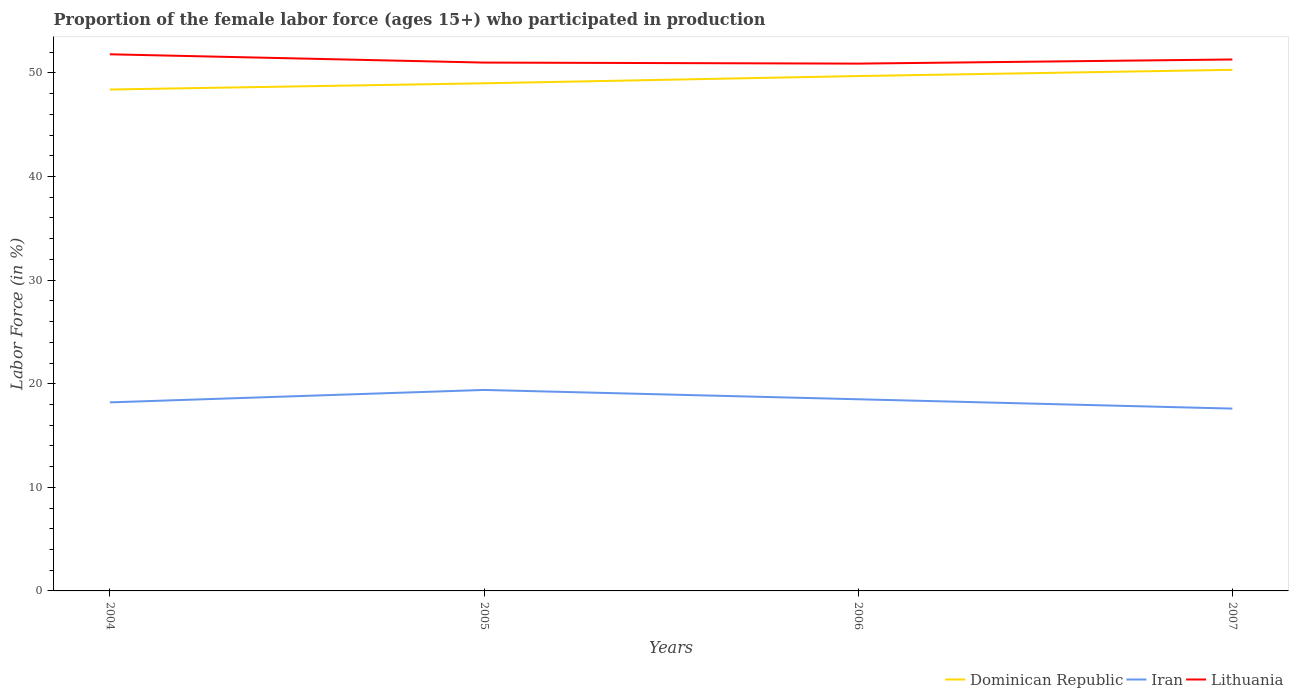How many different coloured lines are there?
Give a very brief answer. 3. Does the line corresponding to Lithuania intersect with the line corresponding to Dominican Republic?
Offer a very short reply. No. Is the number of lines equal to the number of legend labels?
Offer a very short reply. Yes. Across all years, what is the maximum proportion of the female labor force who participated in production in Dominican Republic?
Provide a short and direct response. 48.4. In which year was the proportion of the female labor force who participated in production in Iran maximum?
Ensure brevity in your answer.  2007. What is the total proportion of the female labor force who participated in production in Lithuania in the graph?
Provide a short and direct response. 0.5. What is the difference between the highest and the second highest proportion of the female labor force who participated in production in Iran?
Ensure brevity in your answer.  1.8. What is the difference between the highest and the lowest proportion of the female labor force who participated in production in Iran?
Offer a very short reply. 2. How many years are there in the graph?
Give a very brief answer. 4. What is the difference between two consecutive major ticks on the Y-axis?
Ensure brevity in your answer.  10. Are the values on the major ticks of Y-axis written in scientific E-notation?
Your answer should be compact. No. Where does the legend appear in the graph?
Provide a succinct answer. Bottom right. How are the legend labels stacked?
Make the answer very short. Horizontal. What is the title of the graph?
Make the answer very short. Proportion of the female labor force (ages 15+) who participated in production. What is the Labor Force (in %) in Dominican Republic in 2004?
Offer a very short reply. 48.4. What is the Labor Force (in %) in Iran in 2004?
Provide a succinct answer. 18.2. What is the Labor Force (in %) of Lithuania in 2004?
Your response must be concise. 51.8. What is the Labor Force (in %) in Iran in 2005?
Provide a succinct answer. 19.4. What is the Labor Force (in %) in Lithuania in 2005?
Make the answer very short. 51. What is the Labor Force (in %) in Dominican Republic in 2006?
Your answer should be compact. 49.7. What is the Labor Force (in %) in Iran in 2006?
Your answer should be compact. 18.5. What is the Labor Force (in %) in Lithuania in 2006?
Give a very brief answer. 50.9. What is the Labor Force (in %) of Dominican Republic in 2007?
Give a very brief answer. 50.3. What is the Labor Force (in %) of Iran in 2007?
Provide a succinct answer. 17.6. What is the Labor Force (in %) of Lithuania in 2007?
Offer a very short reply. 51.3. Across all years, what is the maximum Labor Force (in %) in Dominican Republic?
Keep it short and to the point. 50.3. Across all years, what is the maximum Labor Force (in %) in Iran?
Give a very brief answer. 19.4. Across all years, what is the maximum Labor Force (in %) of Lithuania?
Offer a terse response. 51.8. Across all years, what is the minimum Labor Force (in %) of Dominican Republic?
Offer a very short reply. 48.4. Across all years, what is the minimum Labor Force (in %) in Iran?
Offer a terse response. 17.6. Across all years, what is the minimum Labor Force (in %) of Lithuania?
Provide a short and direct response. 50.9. What is the total Labor Force (in %) in Dominican Republic in the graph?
Provide a succinct answer. 197.4. What is the total Labor Force (in %) in Iran in the graph?
Provide a succinct answer. 73.7. What is the total Labor Force (in %) of Lithuania in the graph?
Provide a short and direct response. 205. What is the difference between the Labor Force (in %) in Dominican Republic in 2004 and that in 2005?
Your response must be concise. -0.6. What is the difference between the Labor Force (in %) of Lithuania in 2004 and that in 2005?
Your response must be concise. 0.8. What is the difference between the Labor Force (in %) in Iran in 2004 and that in 2006?
Offer a very short reply. -0.3. What is the difference between the Labor Force (in %) of Dominican Republic in 2004 and that in 2007?
Your answer should be very brief. -1.9. What is the difference between the Labor Force (in %) of Iran in 2004 and that in 2007?
Offer a terse response. 0.6. What is the difference between the Labor Force (in %) of Iran in 2005 and that in 2006?
Your answer should be compact. 0.9. What is the difference between the Labor Force (in %) in Lithuania in 2005 and that in 2006?
Give a very brief answer. 0.1. What is the difference between the Labor Force (in %) in Dominican Republic in 2005 and that in 2007?
Your answer should be very brief. -1.3. What is the difference between the Labor Force (in %) in Iran in 2005 and that in 2007?
Give a very brief answer. 1.8. What is the difference between the Labor Force (in %) in Lithuania in 2005 and that in 2007?
Ensure brevity in your answer.  -0.3. What is the difference between the Labor Force (in %) of Dominican Republic in 2006 and that in 2007?
Give a very brief answer. -0.6. What is the difference between the Labor Force (in %) of Lithuania in 2006 and that in 2007?
Give a very brief answer. -0.4. What is the difference between the Labor Force (in %) in Dominican Republic in 2004 and the Labor Force (in %) in Lithuania in 2005?
Your response must be concise. -2.6. What is the difference between the Labor Force (in %) in Iran in 2004 and the Labor Force (in %) in Lithuania in 2005?
Provide a succinct answer. -32.8. What is the difference between the Labor Force (in %) of Dominican Republic in 2004 and the Labor Force (in %) of Iran in 2006?
Provide a succinct answer. 29.9. What is the difference between the Labor Force (in %) of Dominican Republic in 2004 and the Labor Force (in %) of Lithuania in 2006?
Provide a short and direct response. -2.5. What is the difference between the Labor Force (in %) in Iran in 2004 and the Labor Force (in %) in Lithuania in 2006?
Keep it short and to the point. -32.7. What is the difference between the Labor Force (in %) of Dominican Republic in 2004 and the Labor Force (in %) of Iran in 2007?
Your response must be concise. 30.8. What is the difference between the Labor Force (in %) of Dominican Republic in 2004 and the Labor Force (in %) of Lithuania in 2007?
Offer a very short reply. -2.9. What is the difference between the Labor Force (in %) of Iran in 2004 and the Labor Force (in %) of Lithuania in 2007?
Offer a very short reply. -33.1. What is the difference between the Labor Force (in %) in Dominican Republic in 2005 and the Labor Force (in %) in Iran in 2006?
Offer a terse response. 30.5. What is the difference between the Labor Force (in %) of Iran in 2005 and the Labor Force (in %) of Lithuania in 2006?
Give a very brief answer. -31.5. What is the difference between the Labor Force (in %) in Dominican Republic in 2005 and the Labor Force (in %) in Iran in 2007?
Keep it short and to the point. 31.4. What is the difference between the Labor Force (in %) in Iran in 2005 and the Labor Force (in %) in Lithuania in 2007?
Give a very brief answer. -31.9. What is the difference between the Labor Force (in %) of Dominican Republic in 2006 and the Labor Force (in %) of Iran in 2007?
Offer a terse response. 32.1. What is the difference between the Labor Force (in %) in Dominican Republic in 2006 and the Labor Force (in %) in Lithuania in 2007?
Provide a succinct answer. -1.6. What is the difference between the Labor Force (in %) of Iran in 2006 and the Labor Force (in %) of Lithuania in 2007?
Your answer should be very brief. -32.8. What is the average Labor Force (in %) of Dominican Republic per year?
Offer a very short reply. 49.35. What is the average Labor Force (in %) in Iran per year?
Your answer should be very brief. 18.43. What is the average Labor Force (in %) of Lithuania per year?
Provide a short and direct response. 51.25. In the year 2004, what is the difference between the Labor Force (in %) of Dominican Republic and Labor Force (in %) of Iran?
Keep it short and to the point. 30.2. In the year 2004, what is the difference between the Labor Force (in %) in Iran and Labor Force (in %) in Lithuania?
Offer a very short reply. -33.6. In the year 2005, what is the difference between the Labor Force (in %) in Dominican Republic and Labor Force (in %) in Iran?
Your response must be concise. 29.6. In the year 2005, what is the difference between the Labor Force (in %) of Dominican Republic and Labor Force (in %) of Lithuania?
Give a very brief answer. -2. In the year 2005, what is the difference between the Labor Force (in %) in Iran and Labor Force (in %) in Lithuania?
Make the answer very short. -31.6. In the year 2006, what is the difference between the Labor Force (in %) in Dominican Republic and Labor Force (in %) in Iran?
Offer a very short reply. 31.2. In the year 2006, what is the difference between the Labor Force (in %) in Dominican Republic and Labor Force (in %) in Lithuania?
Offer a terse response. -1.2. In the year 2006, what is the difference between the Labor Force (in %) of Iran and Labor Force (in %) of Lithuania?
Your response must be concise. -32.4. In the year 2007, what is the difference between the Labor Force (in %) in Dominican Republic and Labor Force (in %) in Iran?
Offer a very short reply. 32.7. In the year 2007, what is the difference between the Labor Force (in %) of Iran and Labor Force (in %) of Lithuania?
Your response must be concise. -33.7. What is the ratio of the Labor Force (in %) in Iran in 2004 to that in 2005?
Provide a succinct answer. 0.94. What is the ratio of the Labor Force (in %) of Lithuania in 2004 to that in 2005?
Offer a very short reply. 1.02. What is the ratio of the Labor Force (in %) of Dominican Republic in 2004 to that in 2006?
Keep it short and to the point. 0.97. What is the ratio of the Labor Force (in %) in Iran in 2004 to that in 2006?
Provide a short and direct response. 0.98. What is the ratio of the Labor Force (in %) in Lithuania in 2004 to that in 2006?
Offer a very short reply. 1.02. What is the ratio of the Labor Force (in %) of Dominican Republic in 2004 to that in 2007?
Ensure brevity in your answer.  0.96. What is the ratio of the Labor Force (in %) in Iran in 2004 to that in 2007?
Offer a very short reply. 1.03. What is the ratio of the Labor Force (in %) of Lithuania in 2004 to that in 2007?
Your answer should be very brief. 1.01. What is the ratio of the Labor Force (in %) in Dominican Republic in 2005 to that in 2006?
Provide a succinct answer. 0.99. What is the ratio of the Labor Force (in %) of Iran in 2005 to that in 2006?
Give a very brief answer. 1.05. What is the ratio of the Labor Force (in %) in Lithuania in 2005 to that in 2006?
Your response must be concise. 1. What is the ratio of the Labor Force (in %) of Dominican Republic in 2005 to that in 2007?
Keep it short and to the point. 0.97. What is the ratio of the Labor Force (in %) in Iran in 2005 to that in 2007?
Offer a very short reply. 1.1. What is the ratio of the Labor Force (in %) in Lithuania in 2005 to that in 2007?
Make the answer very short. 0.99. What is the ratio of the Labor Force (in %) in Dominican Republic in 2006 to that in 2007?
Your response must be concise. 0.99. What is the ratio of the Labor Force (in %) in Iran in 2006 to that in 2007?
Make the answer very short. 1.05. What is the ratio of the Labor Force (in %) in Lithuania in 2006 to that in 2007?
Your answer should be compact. 0.99. What is the difference between the highest and the second highest Labor Force (in %) in Dominican Republic?
Make the answer very short. 0.6. What is the difference between the highest and the second highest Labor Force (in %) in Iran?
Keep it short and to the point. 0.9. 